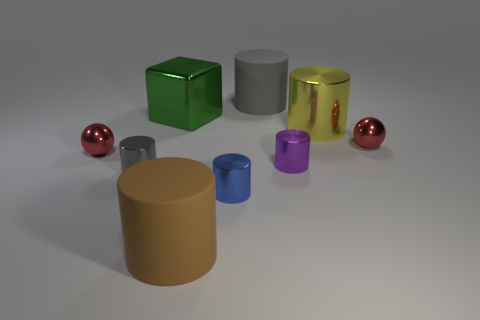Are there an equal number of green objects to the left of the big yellow cylinder and tiny things?
Give a very brief answer. No. There is a rubber cylinder that is to the left of the big gray matte cylinder; is there a purple cylinder that is in front of it?
Your response must be concise. No. What size is the red object that is behind the red object that is on the left side of the matte object behind the big brown rubber object?
Offer a terse response. Small. The large object to the left of the big cylinder in front of the small gray cylinder is made of what material?
Offer a very short reply. Metal. Is there a small gray metal object of the same shape as the yellow metallic object?
Your answer should be compact. Yes. The yellow shiny thing has what shape?
Your response must be concise. Cylinder. There is a gray object behind the tiny metallic thing that is behind the sphere on the left side of the small blue cylinder; what is its material?
Provide a succinct answer. Rubber. Is the number of large brown cylinders that are to the right of the brown object greater than the number of small gray objects?
Your answer should be compact. No. What material is the block that is the same size as the brown rubber cylinder?
Ensure brevity in your answer.  Metal. Are there any cyan spheres of the same size as the yellow object?
Provide a short and direct response. No. 